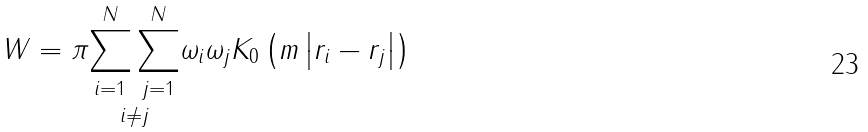Convert formula to latex. <formula><loc_0><loc_0><loc_500><loc_500>W = \pi \underset { i \neq j } { \sum _ { i = 1 } ^ { N } \sum _ { j = 1 } ^ { N } } \omega _ { i } \omega _ { j } K _ { 0 } \left ( m \left | r _ { i } - r _ { j } \right | \right )</formula> 